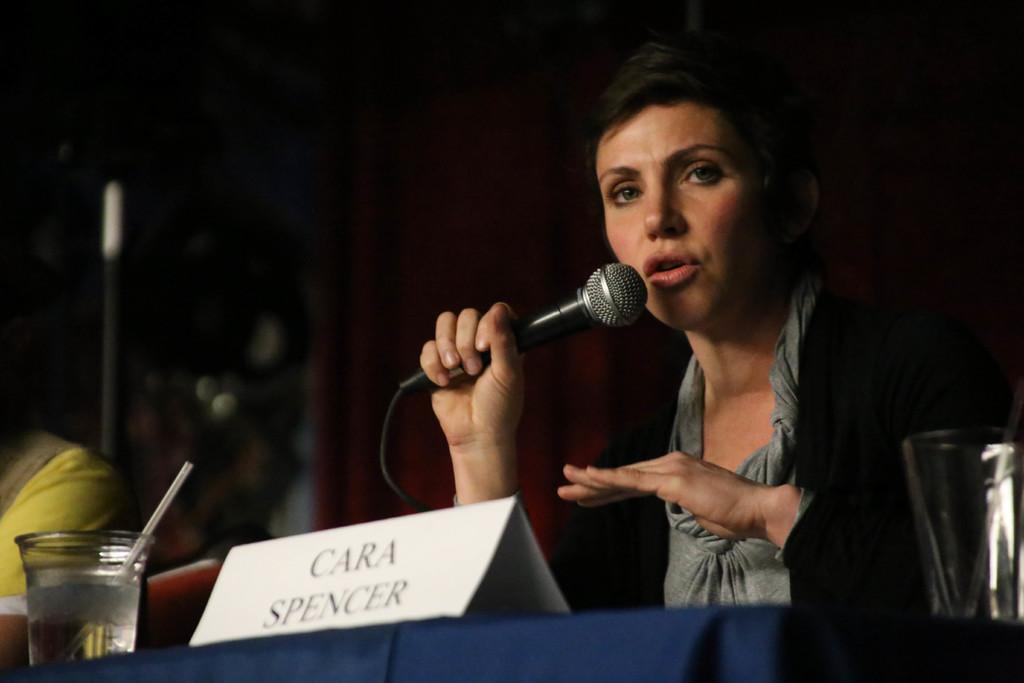Could you give a brief overview of what you see in this image? In this picture there is a woman sitting in the chair in front of a table on which a name plate and glass was placed. She is holding a mic in her hand. Beside her there is another person sitting. 